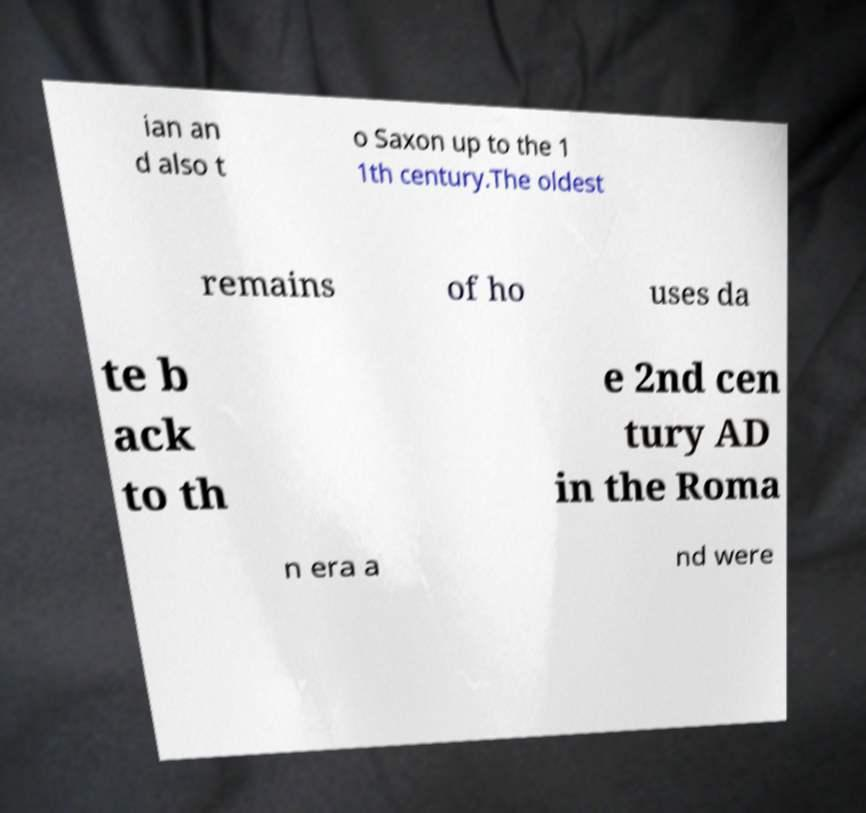What messages or text are displayed in this image? I need them in a readable, typed format. ian an d also t o Saxon up to the 1 1th century.The oldest remains of ho uses da te b ack to th e 2nd cen tury AD in the Roma n era a nd were 